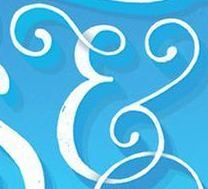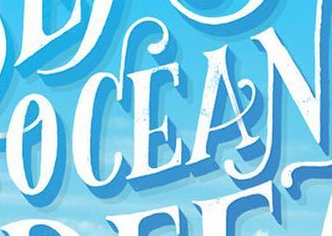Read the text from these images in sequence, separated by a semicolon. &; OCEAN 